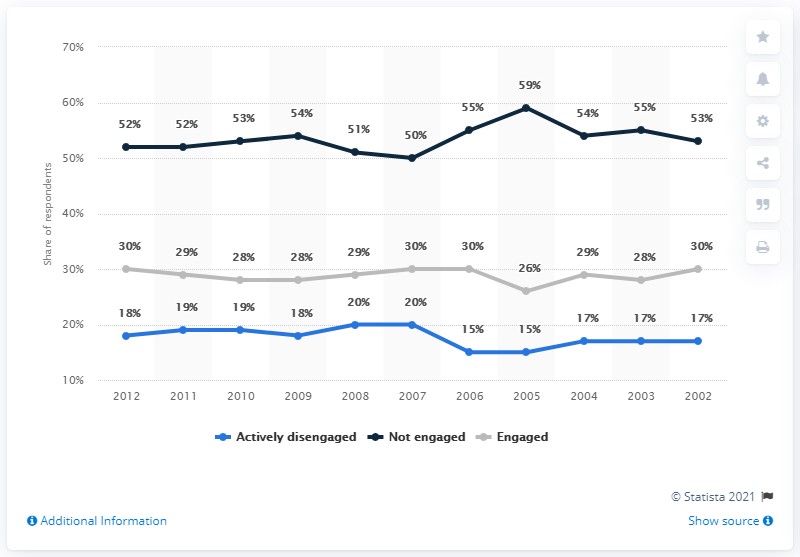Draw attention to some important aspects in this diagram. In 2004, the performance of the colored data line that deviated the most was the black one. 